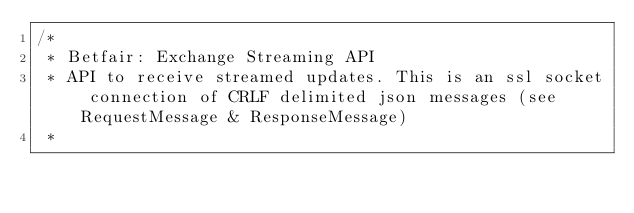<code> <loc_0><loc_0><loc_500><loc_500><_Java_>/*
 * Betfair: Exchange Streaming API
 * API to receive streamed updates. This is an ssl socket connection of CRLF delimited json messages (see RequestMessage & ResponseMessage)
 *</code> 